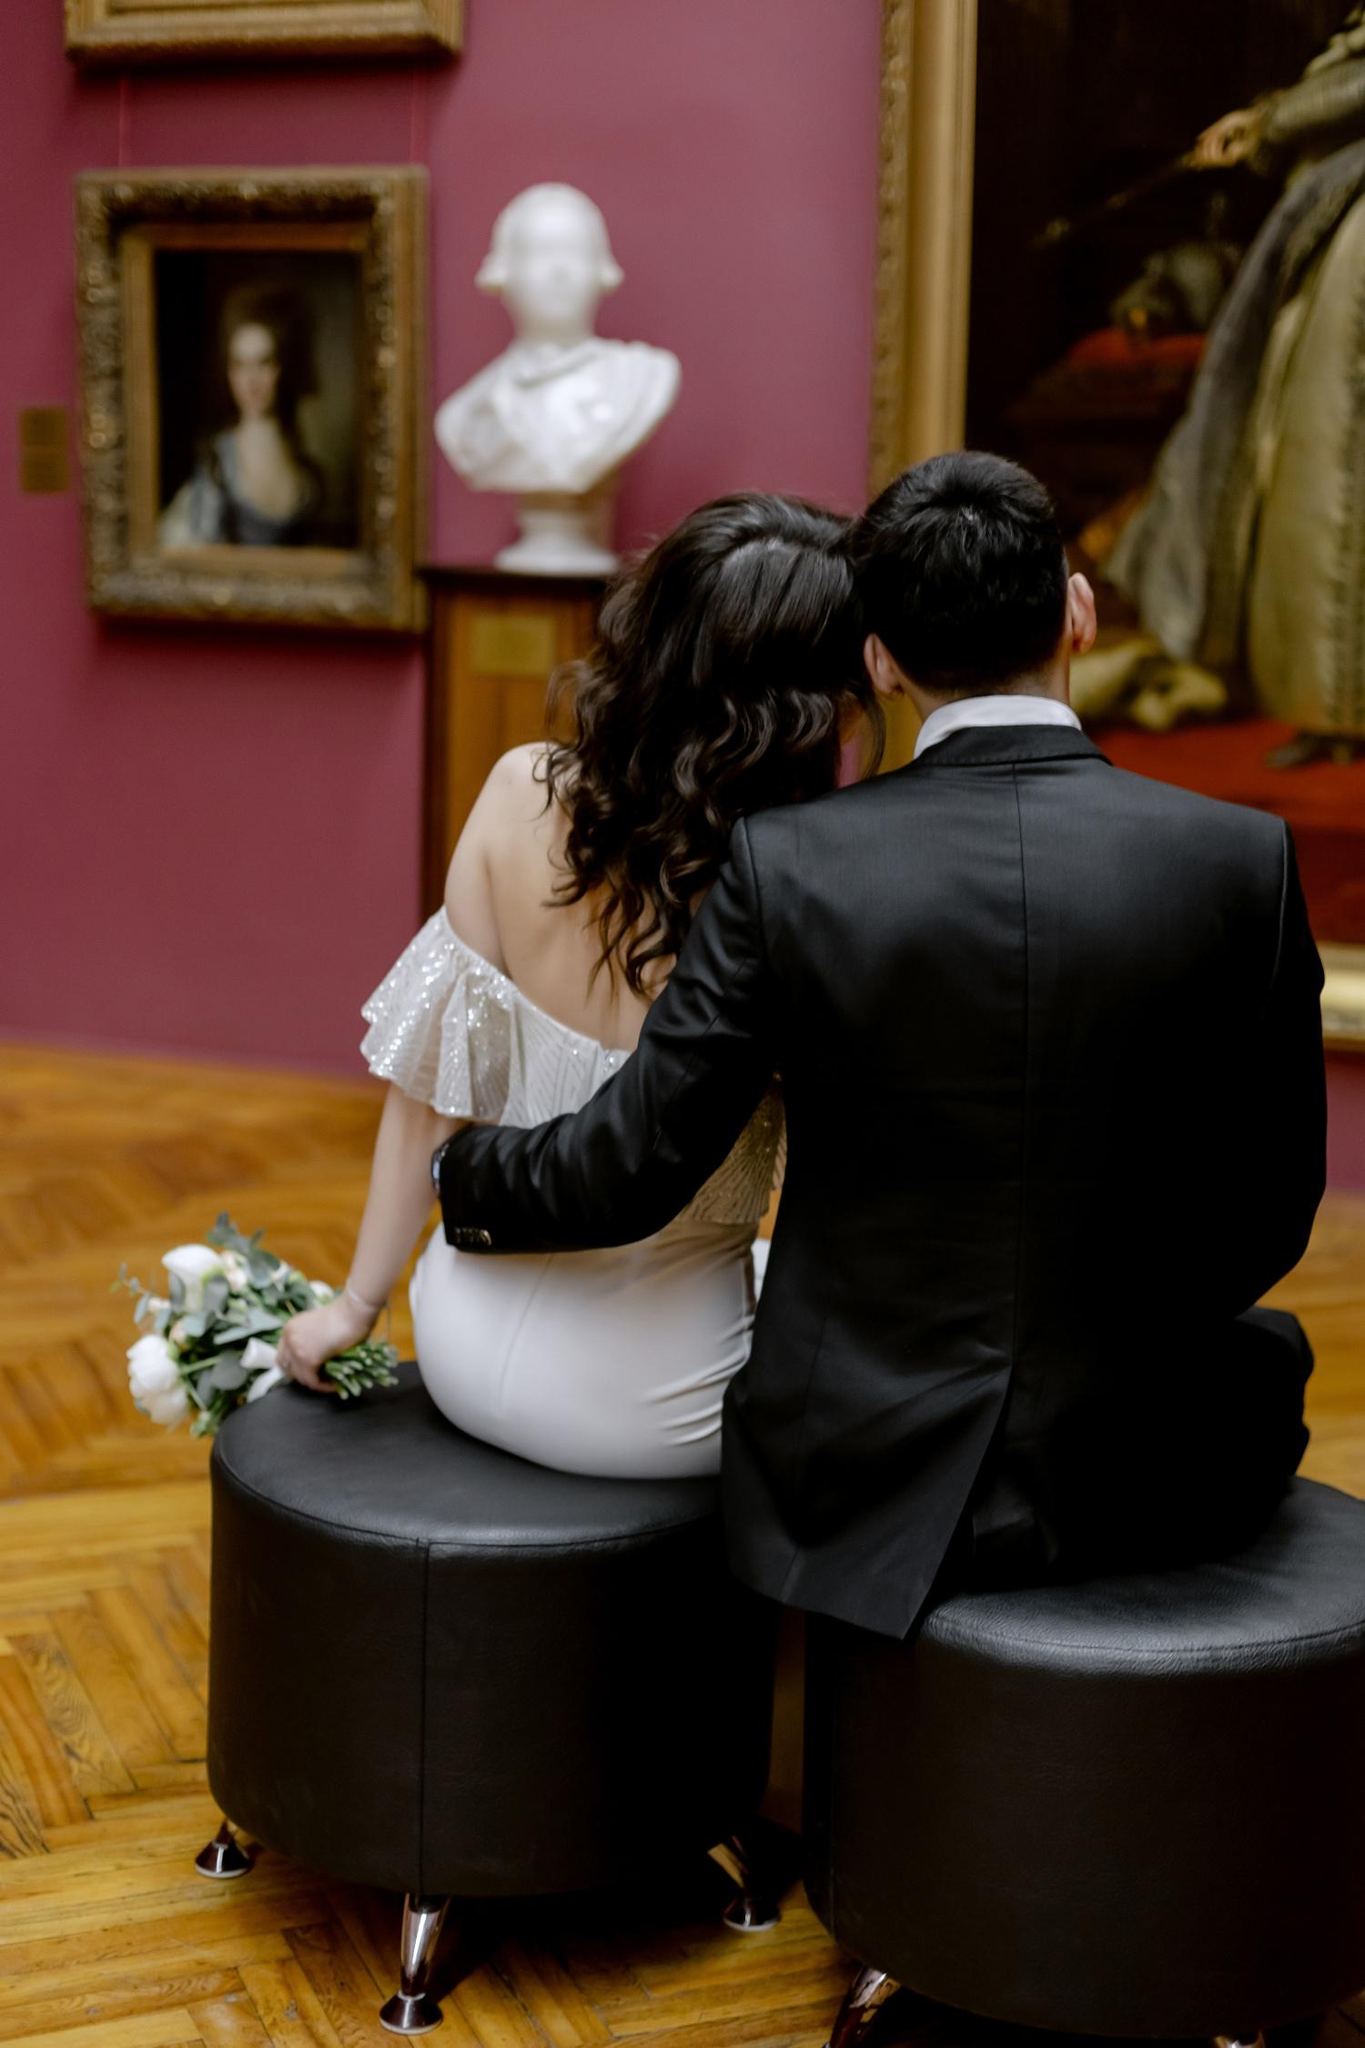What's happening in the scene? The image features a couple in formal wear sitting on a circular bench in an art gallery. The woman is wearing a white off-shoulder dress and is holding a bouquet of white flowers, suggesting a special occasion, possibly a wedding event. The man, in a sleek black suit, sits next to her, and they are both looking at a sculpture and a painting within the gallery. The warm red walls and classic framed artworks suggest an intimate and cultured atmosphere, potentially celebrating their relationship with a private viewing or a quiet moment away from a larger event. 